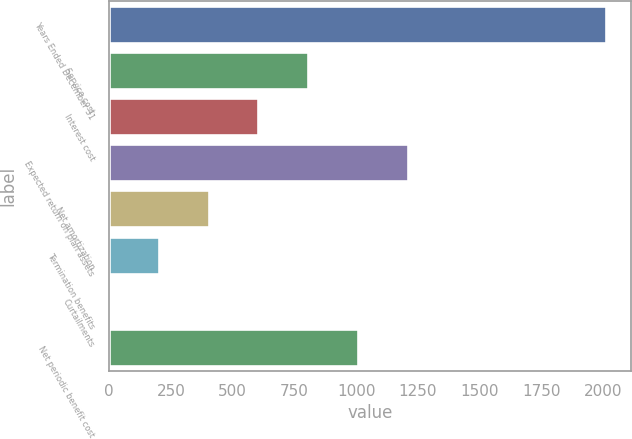Convert chart to OTSL. <chart><loc_0><loc_0><loc_500><loc_500><bar_chart><fcel>Years Ended December 31<fcel>Service cost<fcel>Interest cost<fcel>Expected return on plan assets<fcel>Net amortization<fcel>Termination benefits<fcel>Curtailments<fcel>Net periodic benefit cost<nl><fcel>2013<fcel>805.8<fcel>604.6<fcel>1208.2<fcel>403.4<fcel>202.2<fcel>1<fcel>1007<nl></chart> 